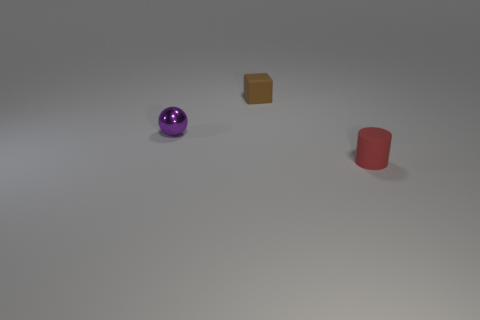Add 1 large cyan cylinders. How many objects exist? 4 Subtract all spheres. How many objects are left? 2 Subtract 0 gray spheres. How many objects are left? 3 Subtract all blue metal balls. Subtract all brown rubber objects. How many objects are left? 2 Add 3 brown objects. How many brown objects are left? 4 Add 2 tiny cyan cylinders. How many tiny cyan cylinders exist? 2 